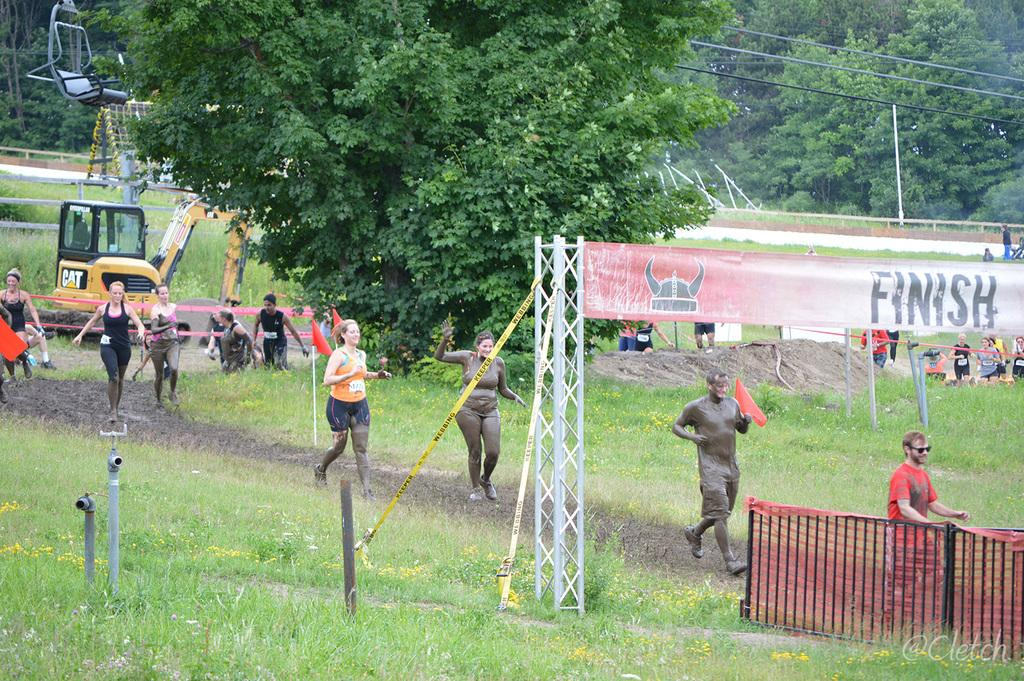<image>
Write a terse but informative summary of the picture. the word finish that is above the ground 